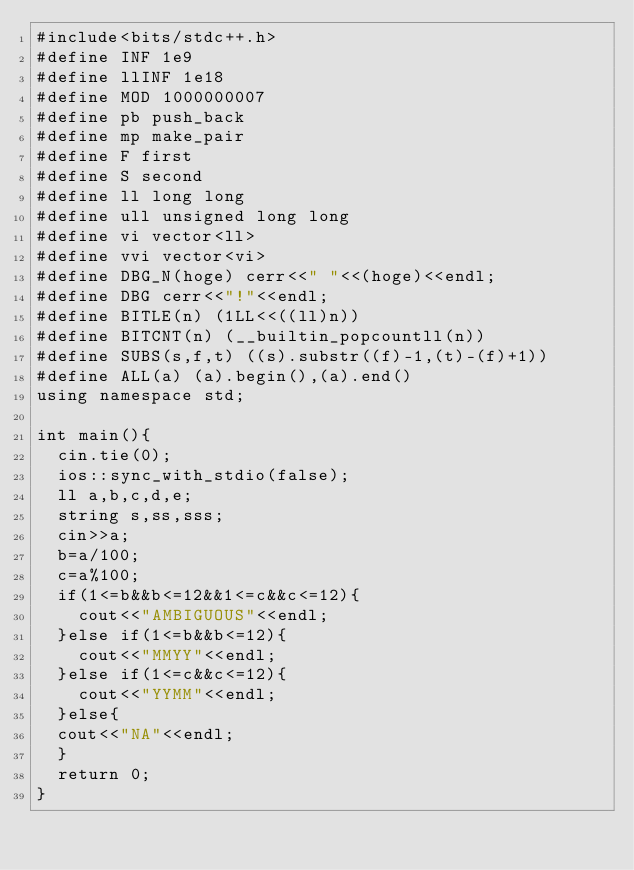Convert code to text. <code><loc_0><loc_0><loc_500><loc_500><_C++_>#include<bits/stdc++.h>
#define INF 1e9
#define llINF 1e18
#define MOD 1000000007
#define pb push_back
#define mp make_pair 
#define F first
#define S second
#define ll long long
#define ull unsigned long long
#define vi vector<ll>
#define vvi vector<vi>
#define DBG_N(hoge) cerr<<" "<<(hoge)<<endl;
#define DBG cerr<<"!"<<endl;
#define BITLE(n) (1LL<<((ll)n))
#define BITCNT(n) (__builtin_popcountll(n))
#define SUBS(s,f,t) ((s).substr((f)-1,(t)-(f)+1))
#define ALL(a) (a).begin(),(a).end()
using namespace std;

int main(){
  cin.tie(0);
  ios::sync_with_stdio(false);
  ll a,b,c,d,e;
  string s,ss,sss;
  cin>>a;
  b=a/100;
  c=a%100;
  if(1<=b&&b<=12&&1<=c&&c<=12){
    cout<<"AMBIGUOUS"<<endl;
  }else if(1<=b&&b<=12){
    cout<<"MMYY"<<endl;
  }else if(1<=c&&c<=12){
    cout<<"YYMM"<<endl;
  }else{
  cout<<"NA"<<endl;
  }
  return 0;
}
</code> 